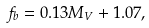<formula> <loc_0><loc_0><loc_500><loc_500>f _ { b } = 0 . 1 3 M _ { V } + 1 . 0 7 ,</formula> 